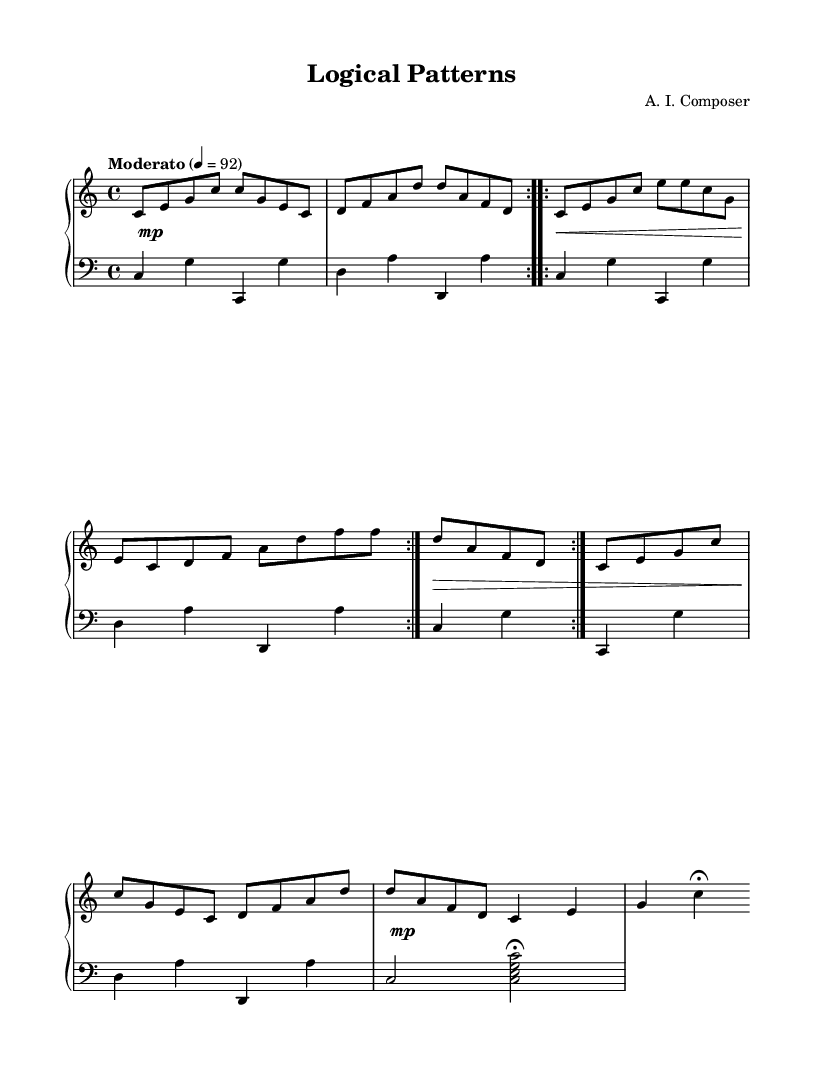What is the key signature of this music? The key signature is C major, which has no sharps or flats indicated. This can be identified at the beginning of the score where the key signature is presented.
Answer: C major What is the time signature of this music? The time signature is 4/4, as shown at the beginning of the score. This notation indicates that there are four beats per measure and the quarter note receives one beat.
Answer: 4/4 What is the tempo marking for this piece? The tempo marking states "Moderato" with a metronome marking of 4 equals 92, which instructs the performer to play at a moderate pace. This can be found at the start of the piece.
Answer: Moderato, 92 How many times is the A section repeated? The A section is repeated twice, which is indicated by the repeat signs (voltas) placed at the beginning and at the end of the section.
Answer: 2 What instruments are specified for this piece? The instrument specified is "acoustic grand," as mentioned in the staff settings for the MIDI instrument. This indicates the type of piano sound to be produced.
Answer: Acoustic grand What dynamic marking is indicated at the beginning of the piece? The dynamic marking is "mp," which means "mezzo piano," indicating a moderate soft play at the beginning of the score. This is the first dynamic instruction provided.
Answer: mp How many sections does the piece have? The piece has four sections: A, B, A'', and Coda. This can be determined by the labeling and structure defined in the composition.
Answer: 4 